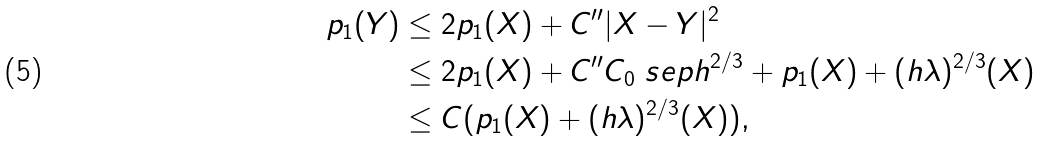<formula> <loc_0><loc_0><loc_500><loc_500>p _ { 1 } ( Y ) & \leq 2 p _ { 1 } ( X ) + C ^ { \prime \prime } | X - Y | ^ { 2 } \\ & \leq 2 p _ { 1 } ( X ) + C ^ { \prime \prime } C _ { 0 } \ s e p { h ^ { 2 / 3 } + p _ { 1 } ( X ) + ( h \lambda ) ^ { 2 / 3 } ( X ) } \\ & \leq C ( p _ { 1 } ( X ) + ( h \lambda ) ^ { 2 / 3 } ( X ) ) ,</formula> 